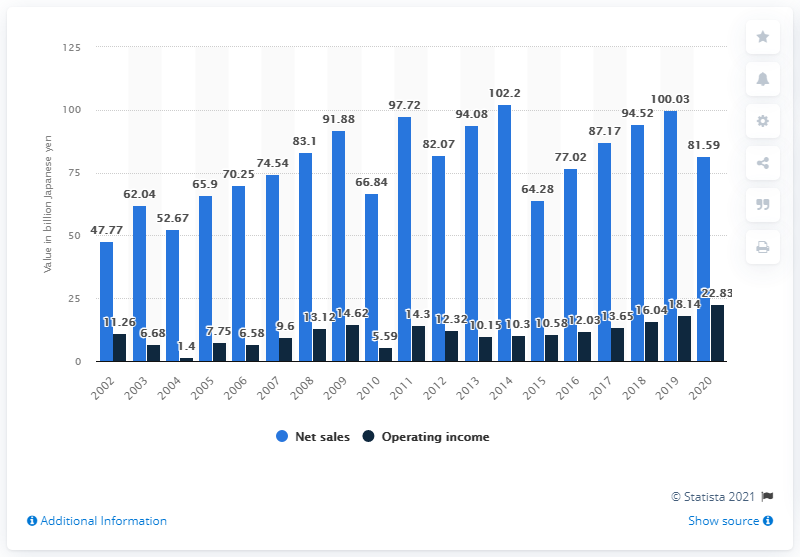Outline some significant characteristics in this image. In Capcom's fiscal year 2020, the company's net sales were 81,590 million yen. 